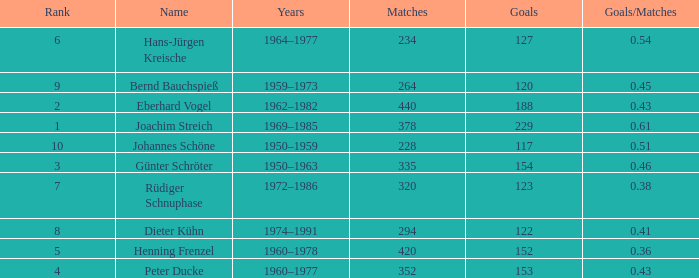How many goals/matches have 153 as the goals with matches greater than 352? None. 